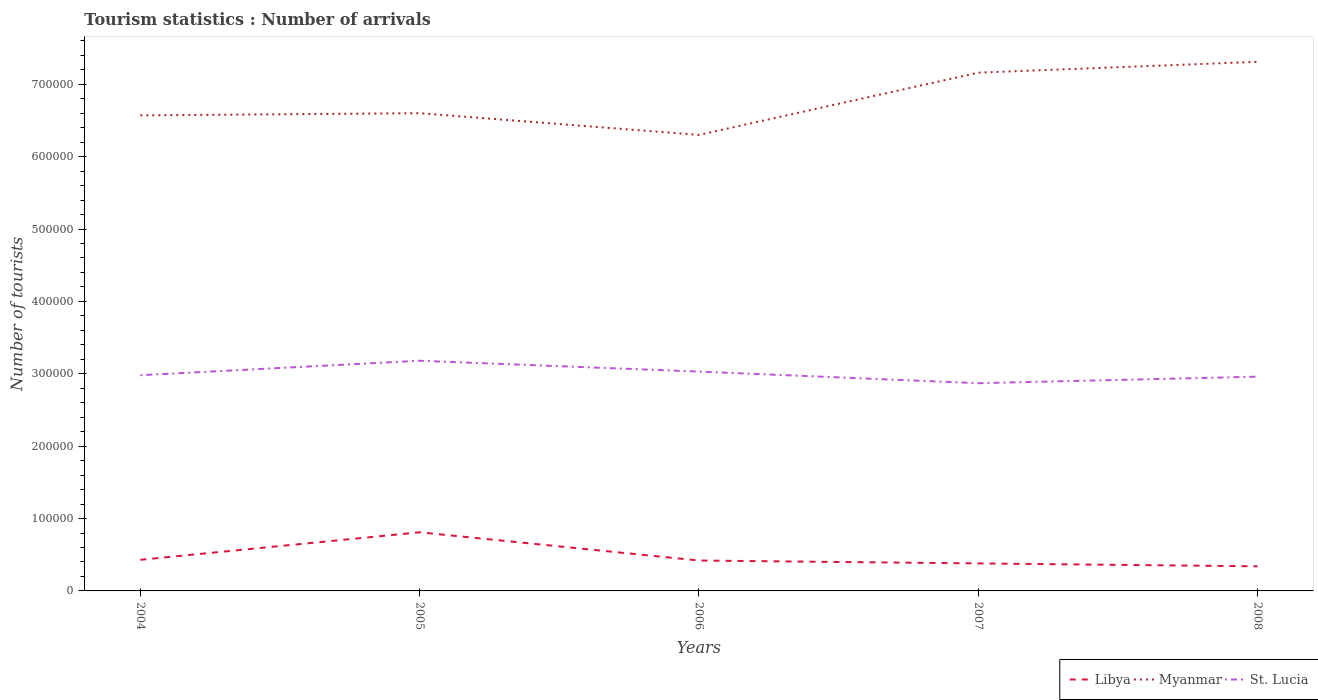Does the line corresponding to Libya intersect with the line corresponding to Myanmar?
Offer a very short reply. No. Is the number of lines equal to the number of legend labels?
Offer a terse response. Yes. Across all years, what is the maximum number of tourist arrivals in Libya?
Your answer should be very brief. 3.40e+04. In which year was the number of tourist arrivals in Myanmar maximum?
Your response must be concise. 2006. What is the total number of tourist arrivals in St. Lucia in the graph?
Your response must be concise. -9000. What is the difference between the highest and the second highest number of tourist arrivals in Libya?
Your response must be concise. 4.70e+04. What is the difference between the highest and the lowest number of tourist arrivals in Libya?
Give a very brief answer. 1. How many years are there in the graph?
Ensure brevity in your answer.  5. What is the difference between two consecutive major ticks on the Y-axis?
Provide a short and direct response. 1.00e+05. Are the values on the major ticks of Y-axis written in scientific E-notation?
Your answer should be compact. No. Does the graph contain any zero values?
Your answer should be very brief. No. Does the graph contain grids?
Make the answer very short. No. How many legend labels are there?
Offer a very short reply. 3. What is the title of the graph?
Offer a terse response. Tourism statistics : Number of arrivals. What is the label or title of the Y-axis?
Keep it short and to the point. Number of tourists. What is the Number of tourists of Libya in 2004?
Your response must be concise. 4.30e+04. What is the Number of tourists of Myanmar in 2004?
Offer a terse response. 6.57e+05. What is the Number of tourists in St. Lucia in 2004?
Make the answer very short. 2.98e+05. What is the Number of tourists in Libya in 2005?
Provide a succinct answer. 8.10e+04. What is the Number of tourists of St. Lucia in 2005?
Offer a terse response. 3.18e+05. What is the Number of tourists in Libya in 2006?
Ensure brevity in your answer.  4.20e+04. What is the Number of tourists of Myanmar in 2006?
Provide a short and direct response. 6.30e+05. What is the Number of tourists of St. Lucia in 2006?
Make the answer very short. 3.03e+05. What is the Number of tourists of Libya in 2007?
Your answer should be compact. 3.80e+04. What is the Number of tourists of Myanmar in 2007?
Make the answer very short. 7.16e+05. What is the Number of tourists of St. Lucia in 2007?
Provide a short and direct response. 2.87e+05. What is the Number of tourists in Libya in 2008?
Your answer should be compact. 3.40e+04. What is the Number of tourists in Myanmar in 2008?
Keep it short and to the point. 7.31e+05. What is the Number of tourists in St. Lucia in 2008?
Make the answer very short. 2.96e+05. Across all years, what is the maximum Number of tourists in Libya?
Keep it short and to the point. 8.10e+04. Across all years, what is the maximum Number of tourists of Myanmar?
Offer a terse response. 7.31e+05. Across all years, what is the maximum Number of tourists of St. Lucia?
Your answer should be compact. 3.18e+05. Across all years, what is the minimum Number of tourists of Libya?
Provide a short and direct response. 3.40e+04. Across all years, what is the minimum Number of tourists in Myanmar?
Provide a short and direct response. 6.30e+05. Across all years, what is the minimum Number of tourists of St. Lucia?
Your answer should be very brief. 2.87e+05. What is the total Number of tourists in Libya in the graph?
Keep it short and to the point. 2.38e+05. What is the total Number of tourists of Myanmar in the graph?
Ensure brevity in your answer.  3.39e+06. What is the total Number of tourists of St. Lucia in the graph?
Provide a short and direct response. 1.50e+06. What is the difference between the Number of tourists in Libya in 2004 and that in 2005?
Offer a terse response. -3.80e+04. What is the difference between the Number of tourists of Myanmar in 2004 and that in 2005?
Keep it short and to the point. -3000. What is the difference between the Number of tourists in Libya in 2004 and that in 2006?
Keep it short and to the point. 1000. What is the difference between the Number of tourists of Myanmar in 2004 and that in 2006?
Offer a very short reply. 2.70e+04. What is the difference between the Number of tourists in St. Lucia in 2004 and that in 2006?
Offer a terse response. -5000. What is the difference between the Number of tourists of Myanmar in 2004 and that in 2007?
Provide a short and direct response. -5.90e+04. What is the difference between the Number of tourists of St. Lucia in 2004 and that in 2007?
Offer a very short reply. 1.10e+04. What is the difference between the Number of tourists of Libya in 2004 and that in 2008?
Your answer should be compact. 9000. What is the difference between the Number of tourists in Myanmar in 2004 and that in 2008?
Ensure brevity in your answer.  -7.40e+04. What is the difference between the Number of tourists of Libya in 2005 and that in 2006?
Provide a succinct answer. 3.90e+04. What is the difference between the Number of tourists in Myanmar in 2005 and that in 2006?
Your answer should be compact. 3.00e+04. What is the difference between the Number of tourists of St. Lucia in 2005 and that in 2006?
Offer a terse response. 1.50e+04. What is the difference between the Number of tourists in Libya in 2005 and that in 2007?
Ensure brevity in your answer.  4.30e+04. What is the difference between the Number of tourists of Myanmar in 2005 and that in 2007?
Your response must be concise. -5.60e+04. What is the difference between the Number of tourists in St. Lucia in 2005 and that in 2007?
Provide a succinct answer. 3.10e+04. What is the difference between the Number of tourists of Libya in 2005 and that in 2008?
Offer a very short reply. 4.70e+04. What is the difference between the Number of tourists in Myanmar in 2005 and that in 2008?
Give a very brief answer. -7.10e+04. What is the difference between the Number of tourists in St. Lucia in 2005 and that in 2008?
Your response must be concise. 2.20e+04. What is the difference between the Number of tourists in Libya in 2006 and that in 2007?
Give a very brief answer. 4000. What is the difference between the Number of tourists of Myanmar in 2006 and that in 2007?
Give a very brief answer. -8.60e+04. What is the difference between the Number of tourists of St. Lucia in 2006 and that in 2007?
Give a very brief answer. 1.60e+04. What is the difference between the Number of tourists of Libya in 2006 and that in 2008?
Make the answer very short. 8000. What is the difference between the Number of tourists in Myanmar in 2006 and that in 2008?
Your response must be concise. -1.01e+05. What is the difference between the Number of tourists in St. Lucia in 2006 and that in 2008?
Provide a succinct answer. 7000. What is the difference between the Number of tourists of Libya in 2007 and that in 2008?
Provide a short and direct response. 4000. What is the difference between the Number of tourists of Myanmar in 2007 and that in 2008?
Keep it short and to the point. -1.50e+04. What is the difference between the Number of tourists in St. Lucia in 2007 and that in 2008?
Keep it short and to the point. -9000. What is the difference between the Number of tourists of Libya in 2004 and the Number of tourists of Myanmar in 2005?
Offer a terse response. -6.17e+05. What is the difference between the Number of tourists of Libya in 2004 and the Number of tourists of St. Lucia in 2005?
Keep it short and to the point. -2.75e+05. What is the difference between the Number of tourists in Myanmar in 2004 and the Number of tourists in St. Lucia in 2005?
Your answer should be very brief. 3.39e+05. What is the difference between the Number of tourists in Libya in 2004 and the Number of tourists in Myanmar in 2006?
Give a very brief answer. -5.87e+05. What is the difference between the Number of tourists of Libya in 2004 and the Number of tourists of St. Lucia in 2006?
Provide a short and direct response. -2.60e+05. What is the difference between the Number of tourists of Myanmar in 2004 and the Number of tourists of St. Lucia in 2006?
Offer a very short reply. 3.54e+05. What is the difference between the Number of tourists of Libya in 2004 and the Number of tourists of Myanmar in 2007?
Offer a terse response. -6.73e+05. What is the difference between the Number of tourists of Libya in 2004 and the Number of tourists of St. Lucia in 2007?
Your answer should be compact. -2.44e+05. What is the difference between the Number of tourists in Myanmar in 2004 and the Number of tourists in St. Lucia in 2007?
Your answer should be very brief. 3.70e+05. What is the difference between the Number of tourists in Libya in 2004 and the Number of tourists in Myanmar in 2008?
Give a very brief answer. -6.88e+05. What is the difference between the Number of tourists of Libya in 2004 and the Number of tourists of St. Lucia in 2008?
Provide a short and direct response. -2.53e+05. What is the difference between the Number of tourists in Myanmar in 2004 and the Number of tourists in St. Lucia in 2008?
Your answer should be very brief. 3.61e+05. What is the difference between the Number of tourists of Libya in 2005 and the Number of tourists of Myanmar in 2006?
Your answer should be very brief. -5.49e+05. What is the difference between the Number of tourists in Libya in 2005 and the Number of tourists in St. Lucia in 2006?
Offer a terse response. -2.22e+05. What is the difference between the Number of tourists in Myanmar in 2005 and the Number of tourists in St. Lucia in 2006?
Your response must be concise. 3.57e+05. What is the difference between the Number of tourists of Libya in 2005 and the Number of tourists of Myanmar in 2007?
Offer a terse response. -6.35e+05. What is the difference between the Number of tourists in Libya in 2005 and the Number of tourists in St. Lucia in 2007?
Provide a succinct answer. -2.06e+05. What is the difference between the Number of tourists in Myanmar in 2005 and the Number of tourists in St. Lucia in 2007?
Make the answer very short. 3.73e+05. What is the difference between the Number of tourists in Libya in 2005 and the Number of tourists in Myanmar in 2008?
Your response must be concise. -6.50e+05. What is the difference between the Number of tourists in Libya in 2005 and the Number of tourists in St. Lucia in 2008?
Offer a very short reply. -2.15e+05. What is the difference between the Number of tourists in Myanmar in 2005 and the Number of tourists in St. Lucia in 2008?
Give a very brief answer. 3.64e+05. What is the difference between the Number of tourists of Libya in 2006 and the Number of tourists of Myanmar in 2007?
Offer a terse response. -6.74e+05. What is the difference between the Number of tourists in Libya in 2006 and the Number of tourists in St. Lucia in 2007?
Make the answer very short. -2.45e+05. What is the difference between the Number of tourists in Myanmar in 2006 and the Number of tourists in St. Lucia in 2007?
Your answer should be very brief. 3.43e+05. What is the difference between the Number of tourists of Libya in 2006 and the Number of tourists of Myanmar in 2008?
Provide a short and direct response. -6.89e+05. What is the difference between the Number of tourists of Libya in 2006 and the Number of tourists of St. Lucia in 2008?
Give a very brief answer. -2.54e+05. What is the difference between the Number of tourists of Myanmar in 2006 and the Number of tourists of St. Lucia in 2008?
Offer a very short reply. 3.34e+05. What is the difference between the Number of tourists of Libya in 2007 and the Number of tourists of Myanmar in 2008?
Your answer should be compact. -6.93e+05. What is the difference between the Number of tourists in Libya in 2007 and the Number of tourists in St. Lucia in 2008?
Keep it short and to the point. -2.58e+05. What is the difference between the Number of tourists in Myanmar in 2007 and the Number of tourists in St. Lucia in 2008?
Give a very brief answer. 4.20e+05. What is the average Number of tourists in Libya per year?
Provide a succinct answer. 4.76e+04. What is the average Number of tourists in Myanmar per year?
Your answer should be compact. 6.79e+05. What is the average Number of tourists in St. Lucia per year?
Give a very brief answer. 3.00e+05. In the year 2004, what is the difference between the Number of tourists of Libya and Number of tourists of Myanmar?
Ensure brevity in your answer.  -6.14e+05. In the year 2004, what is the difference between the Number of tourists in Libya and Number of tourists in St. Lucia?
Ensure brevity in your answer.  -2.55e+05. In the year 2004, what is the difference between the Number of tourists of Myanmar and Number of tourists of St. Lucia?
Offer a terse response. 3.59e+05. In the year 2005, what is the difference between the Number of tourists of Libya and Number of tourists of Myanmar?
Ensure brevity in your answer.  -5.79e+05. In the year 2005, what is the difference between the Number of tourists of Libya and Number of tourists of St. Lucia?
Offer a very short reply. -2.37e+05. In the year 2005, what is the difference between the Number of tourists of Myanmar and Number of tourists of St. Lucia?
Ensure brevity in your answer.  3.42e+05. In the year 2006, what is the difference between the Number of tourists in Libya and Number of tourists in Myanmar?
Your answer should be compact. -5.88e+05. In the year 2006, what is the difference between the Number of tourists in Libya and Number of tourists in St. Lucia?
Provide a short and direct response. -2.61e+05. In the year 2006, what is the difference between the Number of tourists of Myanmar and Number of tourists of St. Lucia?
Give a very brief answer. 3.27e+05. In the year 2007, what is the difference between the Number of tourists of Libya and Number of tourists of Myanmar?
Provide a short and direct response. -6.78e+05. In the year 2007, what is the difference between the Number of tourists in Libya and Number of tourists in St. Lucia?
Give a very brief answer. -2.49e+05. In the year 2007, what is the difference between the Number of tourists in Myanmar and Number of tourists in St. Lucia?
Offer a very short reply. 4.29e+05. In the year 2008, what is the difference between the Number of tourists in Libya and Number of tourists in Myanmar?
Your response must be concise. -6.97e+05. In the year 2008, what is the difference between the Number of tourists of Libya and Number of tourists of St. Lucia?
Make the answer very short. -2.62e+05. In the year 2008, what is the difference between the Number of tourists of Myanmar and Number of tourists of St. Lucia?
Ensure brevity in your answer.  4.35e+05. What is the ratio of the Number of tourists of Libya in 2004 to that in 2005?
Your response must be concise. 0.53. What is the ratio of the Number of tourists of St. Lucia in 2004 to that in 2005?
Give a very brief answer. 0.94. What is the ratio of the Number of tourists in Libya in 2004 to that in 2006?
Give a very brief answer. 1.02. What is the ratio of the Number of tourists in Myanmar in 2004 to that in 2006?
Provide a succinct answer. 1.04. What is the ratio of the Number of tourists in St. Lucia in 2004 to that in 2006?
Your response must be concise. 0.98. What is the ratio of the Number of tourists of Libya in 2004 to that in 2007?
Provide a short and direct response. 1.13. What is the ratio of the Number of tourists in Myanmar in 2004 to that in 2007?
Give a very brief answer. 0.92. What is the ratio of the Number of tourists in St. Lucia in 2004 to that in 2007?
Give a very brief answer. 1.04. What is the ratio of the Number of tourists of Libya in 2004 to that in 2008?
Offer a very short reply. 1.26. What is the ratio of the Number of tourists of Myanmar in 2004 to that in 2008?
Keep it short and to the point. 0.9. What is the ratio of the Number of tourists in St. Lucia in 2004 to that in 2008?
Keep it short and to the point. 1.01. What is the ratio of the Number of tourists in Libya in 2005 to that in 2006?
Offer a terse response. 1.93. What is the ratio of the Number of tourists in Myanmar in 2005 to that in 2006?
Offer a very short reply. 1.05. What is the ratio of the Number of tourists in St. Lucia in 2005 to that in 2006?
Your answer should be very brief. 1.05. What is the ratio of the Number of tourists in Libya in 2005 to that in 2007?
Offer a very short reply. 2.13. What is the ratio of the Number of tourists in Myanmar in 2005 to that in 2007?
Give a very brief answer. 0.92. What is the ratio of the Number of tourists in St. Lucia in 2005 to that in 2007?
Give a very brief answer. 1.11. What is the ratio of the Number of tourists of Libya in 2005 to that in 2008?
Provide a short and direct response. 2.38. What is the ratio of the Number of tourists in Myanmar in 2005 to that in 2008?
Offer a terse response. 0.9. What is the ratio of the Number of tourists of St. Lucia in 2005 to that in 2008?
Your response must be concise. 1.07. What is the ratio of the Number of tourists of Libya in 2006 to that in 2007?
Offer a very short reply. 1.11. What is the ratio of the Number of tourists in Myanmar in 2006 to that in 2007?
Offer a terse response. 0.88. What is the ratio of the Number of tourists in St. Lucia in 2006 to that in 2007?
Your response must be concise. 1.06. What is the ratio of the Number of tourists of Libya in 2006 to that in 2008?
Provide a succinct answer. 1.24. What is the ratio of the Number of tourists in Myanmar in 2006 to that in 2008?
Your answer should be compact. 0.86. What is the ratio of the Number of tourists in St. Lucia in 2006 to that in 2008?
Offer a very short reply. 1.02. What is the ratio of the Number of tourists of Libya in 2007 to that in 2008?
Give a very brief answer. 1.12. What is the ratio of the Number of tourists in Myanmar in 2007 to that in 2008?
Make the answer very short. 0.98. What is the ratio of the Number of tourists of St. Lucia in 2007 to that in 2008?
Offer a terse response. 0.97. What is the difference between the highest and the second highest Number of tourists of Libya?
Your answer should be compact. 3.80e+04. What is the difference between the highest and the second highest Number of tourists of Myanmar?
Your answer should be very brief. 1.50e+04. What is the difference between the highest and the second highest Number of tourists of St. Lucia?
Your response must be concise. 1.50e+04. What is the difference between the highest and the lowest Number of tourists of Libya?
Ensure brevity in your answer.  4.70e+04. What is the difference between the highest and the lowest Number of tourists in Myanmar?
Provide a succinct answer. 1.01e+05. What is the difference between the highest and the lowest Number of tourists of St. Lucia?
Your answer should be very brief. 3.10e+04. 